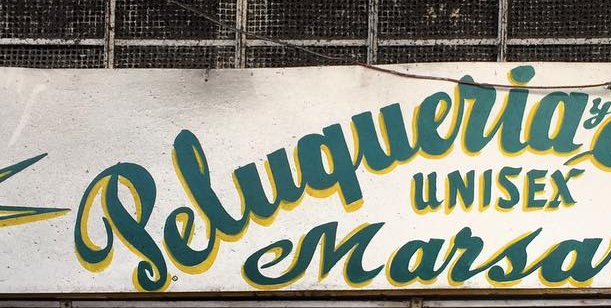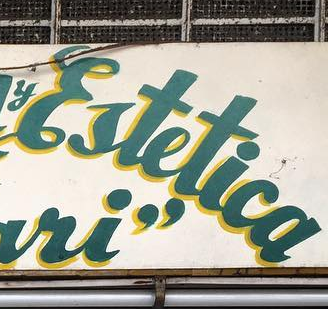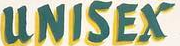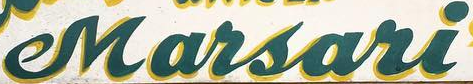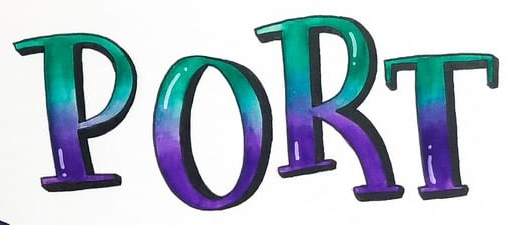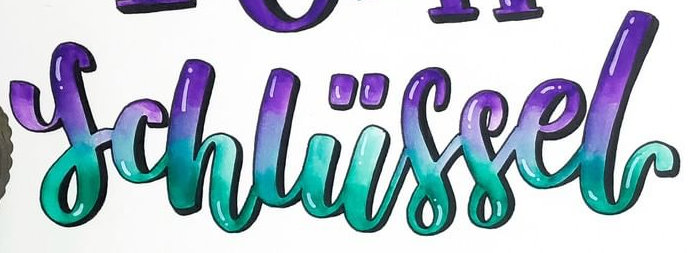What words can you see in these images in sequence, separated by a semicolon? Peluqueria; Ertetica; UNISEX; Marsari; PORT; schliissel 